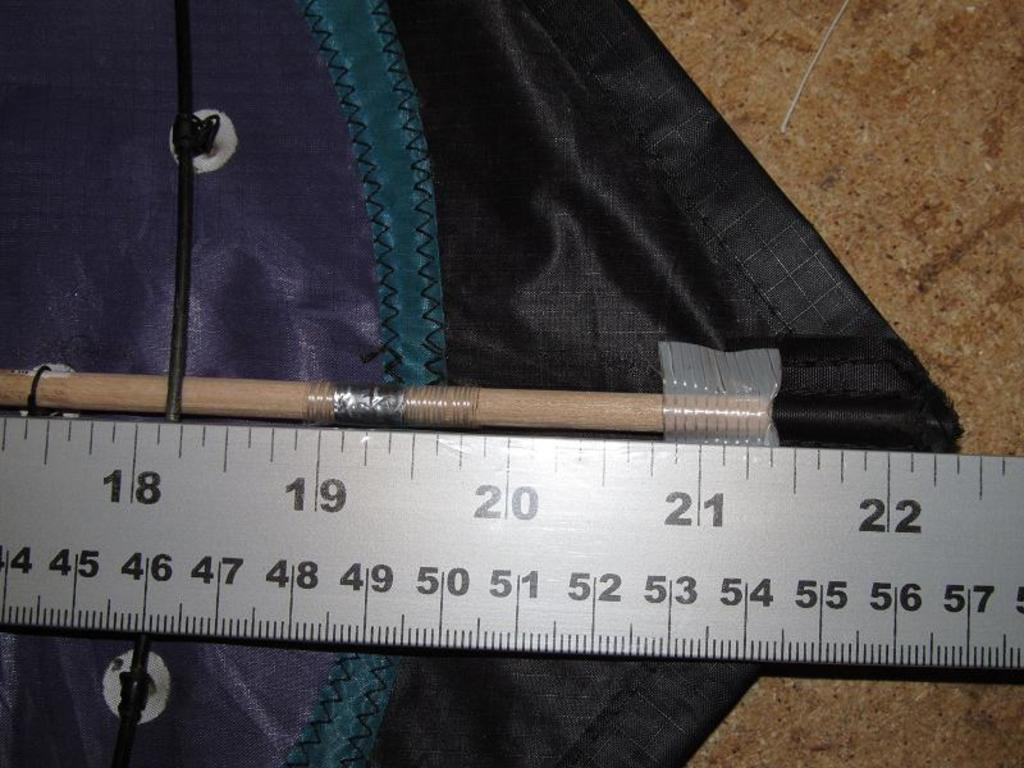<image>
Relay a brief, clear account of the picture shown. Ruler that goes up to 22 measuring a pencil. 